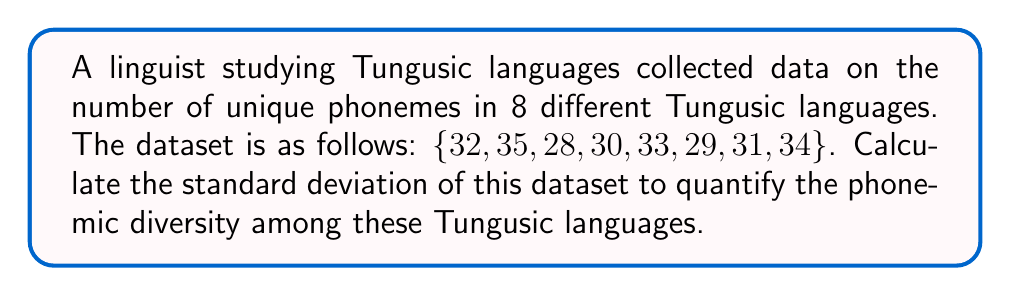Could you help me with this problem? To calculate the standard deviation, we'll follow these steps:

1. Calculate the mean ($\mu$) of the dataset:
   $$\mu = \frac{32 + 35 + 28 + 30 + 33 + 29 + 31 + 34}{8} = \frac{252}{8} = 31.5$$

2. Calculate the squared differences from the mean:
   $$(32 - 31.5)^2 = 0.25$$
   $$(35 - 31.5)^2 = 12.25$$
   $$(28 - 31.5)^2 = 12.25$$
   $$(30 - 31.5)^2 = 2.25$$
   $$(33 - 31.5)^2 = 2.25$$
   $$(29 - 31.5)^2 = 6.25$$
   $$(31 - 31.5)^2 = 0.25$$
   $$(34 - 31.5)^2 = 6.25$$

3. Calculate the variance ($\sigma^2$) by taking the mean of these squared differences:
   $$\sigma^2 = \frac{0.25 + 12.25 + 12.25 + 2.25 + 2.25 + 6.25 + 0.25 + 6.25}{8} = \frac{42}{8} = 5.25$$

4. Calculate the standard deviation ($\sigma$) by taking the square root of the variance:
   $$\sigma = \sqrt{5.25} \approx 2.2913$$

Therefore, the standard deviation of the phoneme counts in these Tungusic languages is approximately 2.2913.
Answer: 2.2913 